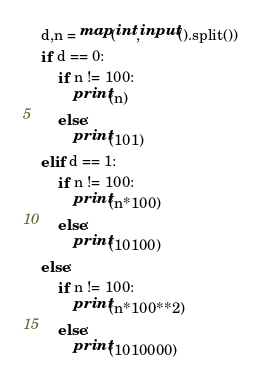Convert code to text. <code><loc_0><loc_0><loc_500><loc_500><_Python_>d,n = map(int,input().split())
if d == 0:
    if n != 100:
        print(n)
    else:
        print(101)
elif d == 1:
    if n != 100:
        print(n*100)
    else:
        print(10100)
else:
    if n != 100:
        print(n*100**2)
    else:
        print(1010000)</code> 